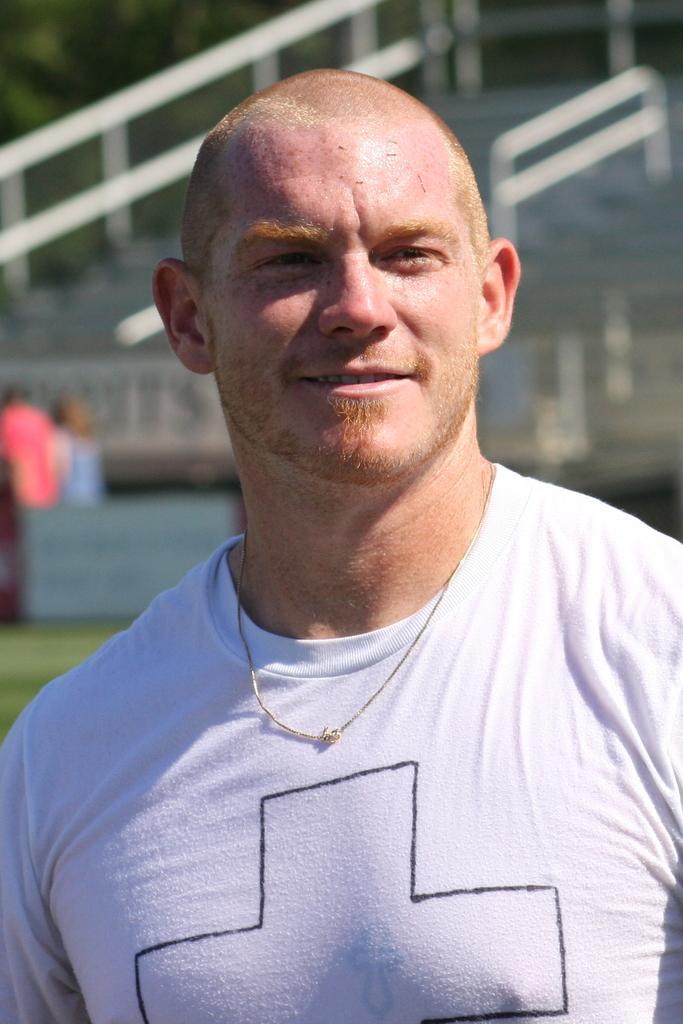Describe this image in one or two sentences. In this image in the foreground there is one person who is wearing a white t-shirt, and in the background there is a railing, staircase and some persons and trees. 